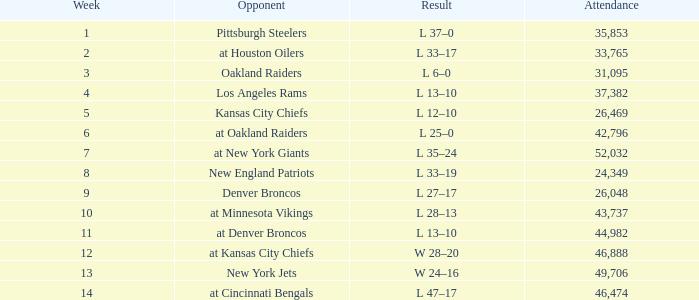What is the lowest Week when the result was l 13–10, November 30, 1975, with more than 44,982 people in attendance? None. 